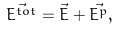Convert formula to latex. <formula><loc_0><loc_0><loc_500><loc_500>\vec { E ^ { t o t } } = \vec { E } + \vec { E ^ { p } } ,</formula> 